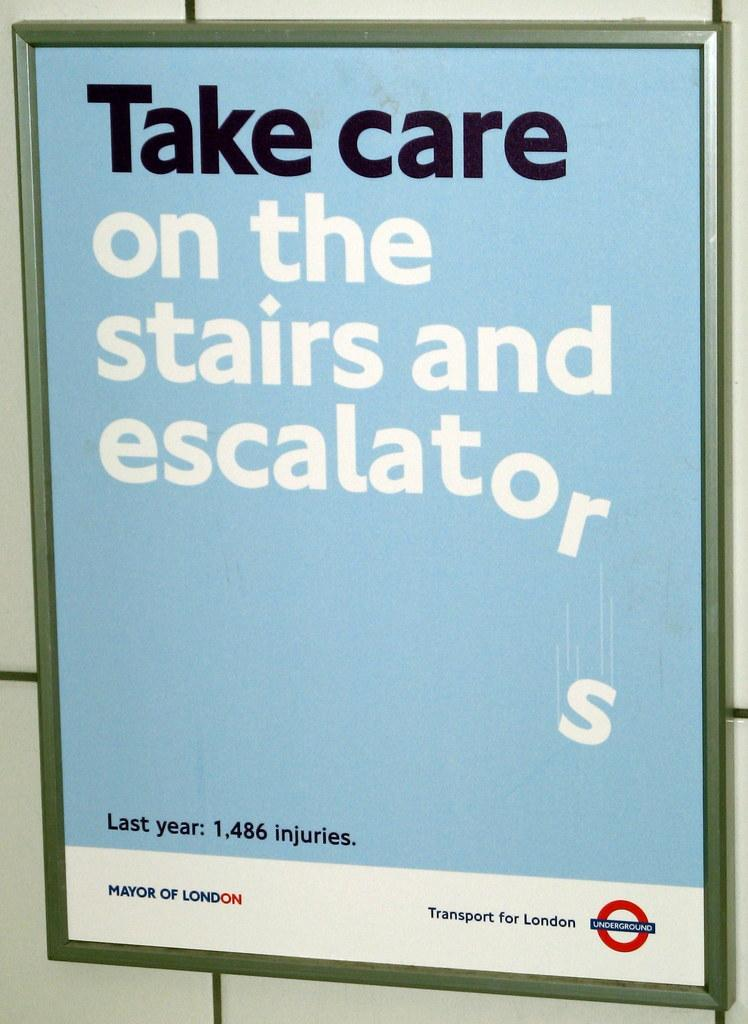<image>
Render a clear and concise summary of the photo. An underground poster reading Take care on the stairs and escalators. 